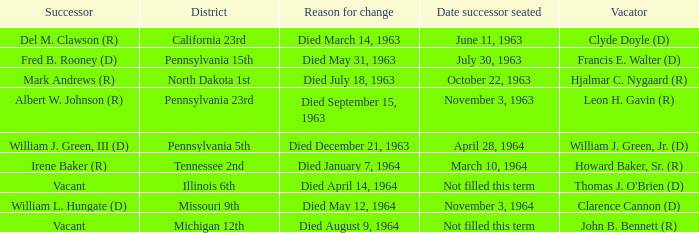Who are all successors when reason for change is died May 12, 1964? William L. Hungate (D). 